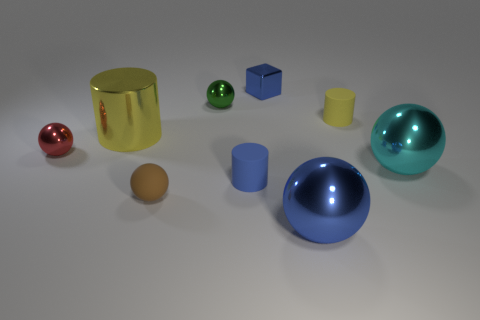Subtract all red spheres. How many spheres are left? 4 Subtract 1 balls. How many balls are left? 4 Subtract all blue spheres. How many spheres are left? 4 Subtract all gray balls. Subtract all blue cubes. How many balls are left? 5 Add 1 tiny green spheres. How many objects exist? 10 Subtract all cubes. How many objects are left? 8 Add 1 tiny yellow rubber things. How many tiny yellow rubber things are left? 2 Add 3 big red rubber objects. How many big red rubber objects exist? 3 Subtract 0 gray spheres. How many objects are left? 9 Subtract all small green things. Subtract all small objects. How many objects are left? 2 